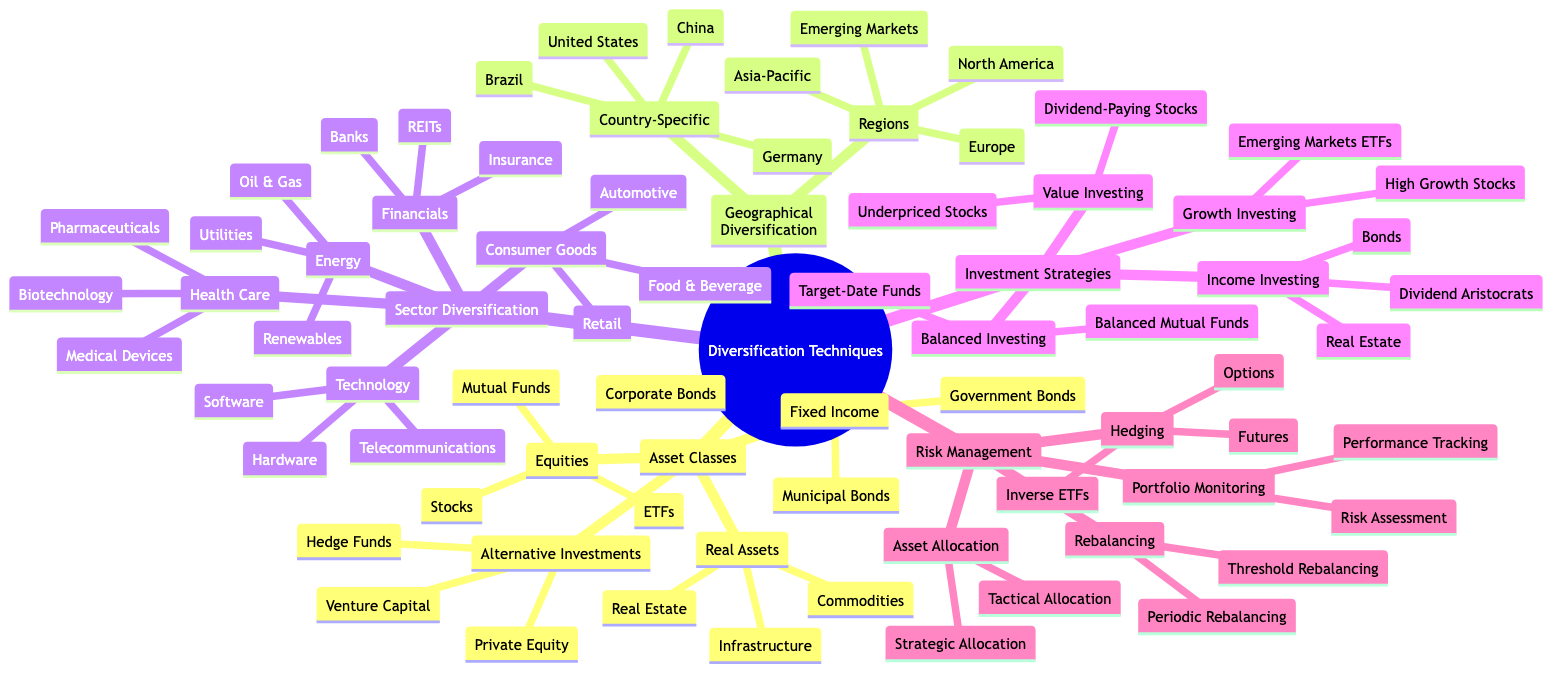What are the four main asset classes? The diagram outlines four major asset classes under 'Asset Classes': Equities, Fixed Income, Real Assets, and Alternative Investments.
Answer: Equities, Fixed Income, Real Assets, Alternative Investments How many types of Investment Strategies are listed? In the 'Investment Strategies' section, there are four distinct types mentioned: Growth Investing, Value Investing, Income Investing, and Balanced Investing.
Answer: Four Which sector includes automotive as a subcategory? Looking under 'Sector Diversification,' the category 'Consumer Goods' lists 'Automotive' as one of its subcategories.
Answer: Consumer Goods What is one type of hedging mentioned? In the 'Risk Management' section, one specific type of hedging listed is 'Options.'
Answer: Options Name one type of alternative investment. Under 'Alternative Investments,' the diagram includes 'Hedge Funds' as one example of this category.
Answer: Hedge Funds How many regions are indicated for geographical diversification? The 'Geographical Diversification' section specifies four regions listed: North America, Europe, Asia-Pacific, and Emerging Markets.
Answer: Four What strategy could be used for income investing? The 'Income Investing' category under 'Investment Strategies' lists 'Bonds' as one specific strategy that could be utilized.
Answer: Bonds Which asset class has government bonds? The 'Fixed Income' asset class specifically mentions 'Government Bonds' as one of its components.
Answer: Fixed Income What type of rebalancing is mentioned? In the 'Risk Management' section, 'Periodic Rebalancing' is mentioned as one of the types of rebalancing strategies.
Answer: Periodic Rebalancing 